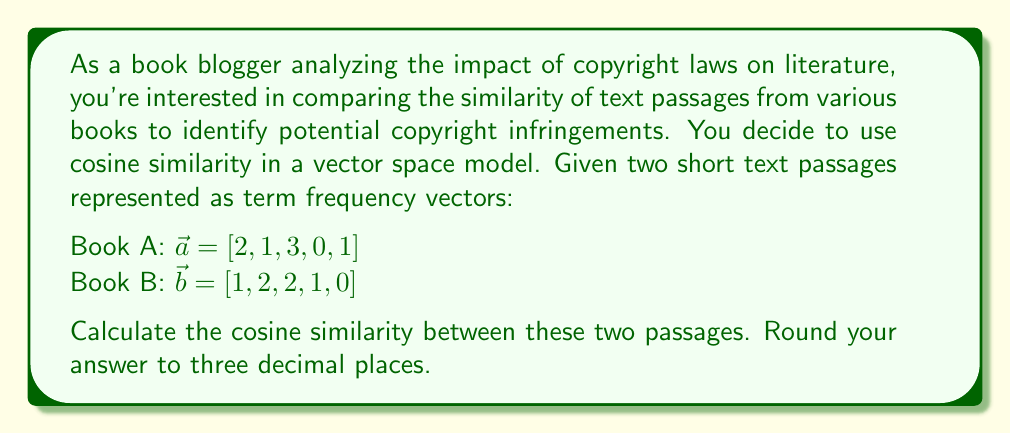Show me your answer to this math problem. To calculate the cosine similarity between two vectors in a vector space model, we use the following formula:

$$\text{cosine similarity} = \frac{\vec{a} \cdot \vec{b}}{|\vec{a}| |\vec{b}|}$$

Where $\vec{a} \cdot \vec{b}$ is the dot product of the vectors, and $|\vec{a}|$ and $|\vec{b}|$ are the magnitudes of vectors $\vec{a}$ and $\vec{b}$ respectively.

Step 1: Calculate the dot product $\vec{a} \cdot \vec{b}$
$$\vec{a} \cdot \vec{b} = (2 \times 1) + (1 \times 2) + (3 \times 2) + (0 \times 1) + (1 \times 0) = 2 + 2 + 6 + 0 + 0 = 10$$

Step 2: Calculate the magnitude of $\vec{a}$
$$|\vec{a}| = \sqrt{2^2 + 1^2 + 3^2 + 0^2 + 1^2} = \sqrt{4 + 1 + 9 + 0 + 1} = \sqrt{15} \approx 3.873$$

Step 3: Calculate the magnitude of $\vec{b}$
$$|\vec{b}| = \sqrt{1^2 + 2^2 + 2^2 + 1^2 + 0^2} = \sqrt{1 + 4 + 4 + 1 + 0} = \sqrt{10} \approx 3.162$$

Step 4: Apply the cosine similarity formula
$$\text{cosine similarity} = \frac{10}{3.873 \times 3.162} \approx 0.816$$

Step 5: Round the result to three decimal places
$$\text{cosine similarity} \approx 0.816$$
Answer: 0.816 